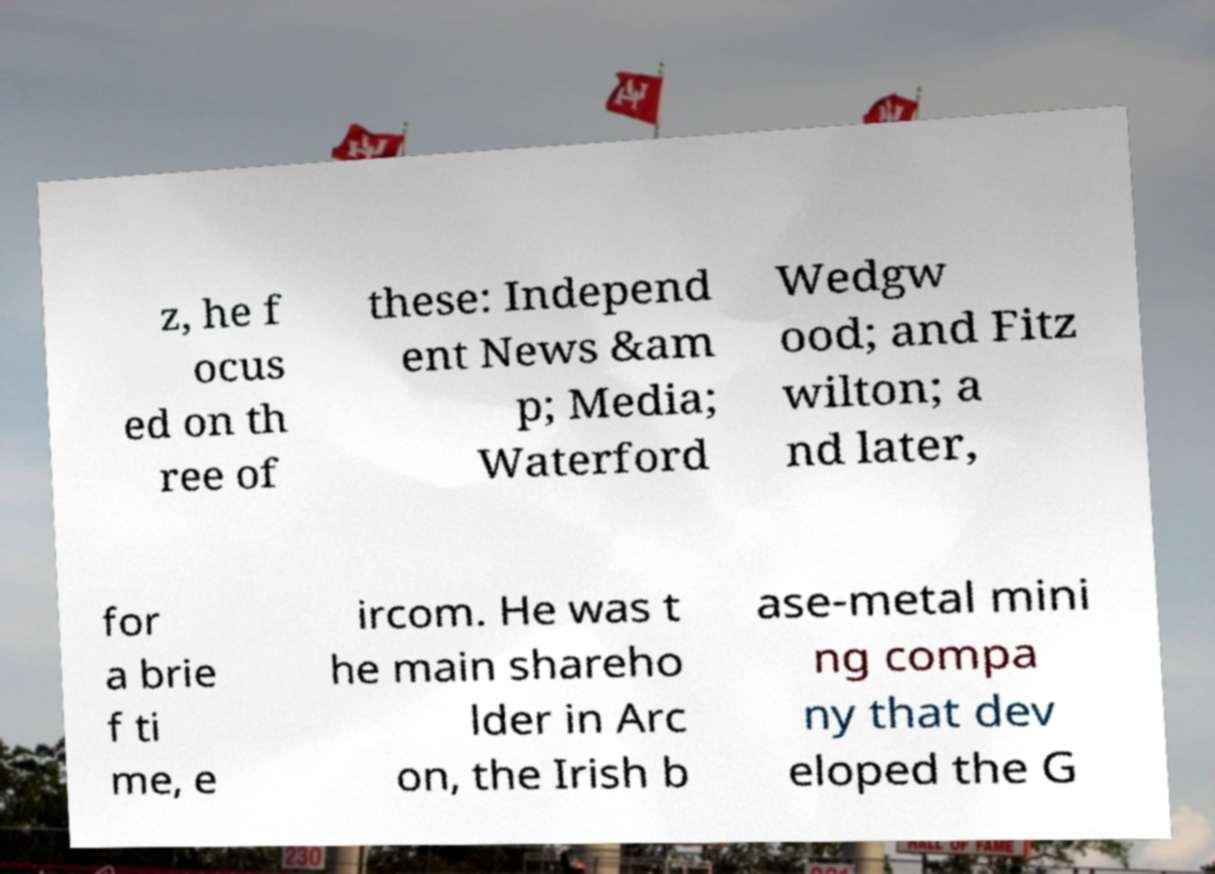Can you accurately transcribe the text from the provided image for me? z, he f ocus ed on th ree of these: Independ ent News &am p; Media; Waterford Wedgw ood; and Fitz wilton; a nd later, for a brie f ti me, e ircom. He was t he main shareho lder in Arc on, the Irish b ase-metal mini ng compa ny that dev eloped the G 